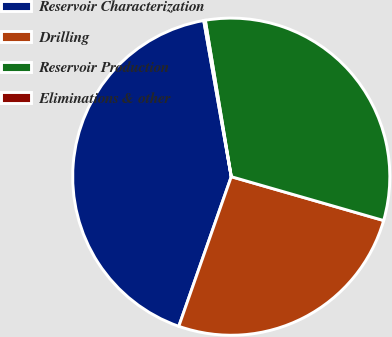Convert chart to OTSL. <chart><loc_0><loc_0><loc_500><loc_500><pie_chart><fcel>Reservoir Characterization<fcel>Drilling<fcel>Reservoir Production<fcel>Eliminations & other<nl><fcel>41.86%<fcel>25.91%<fcel>32.08%<fcel>0.16%<nl></chart> 